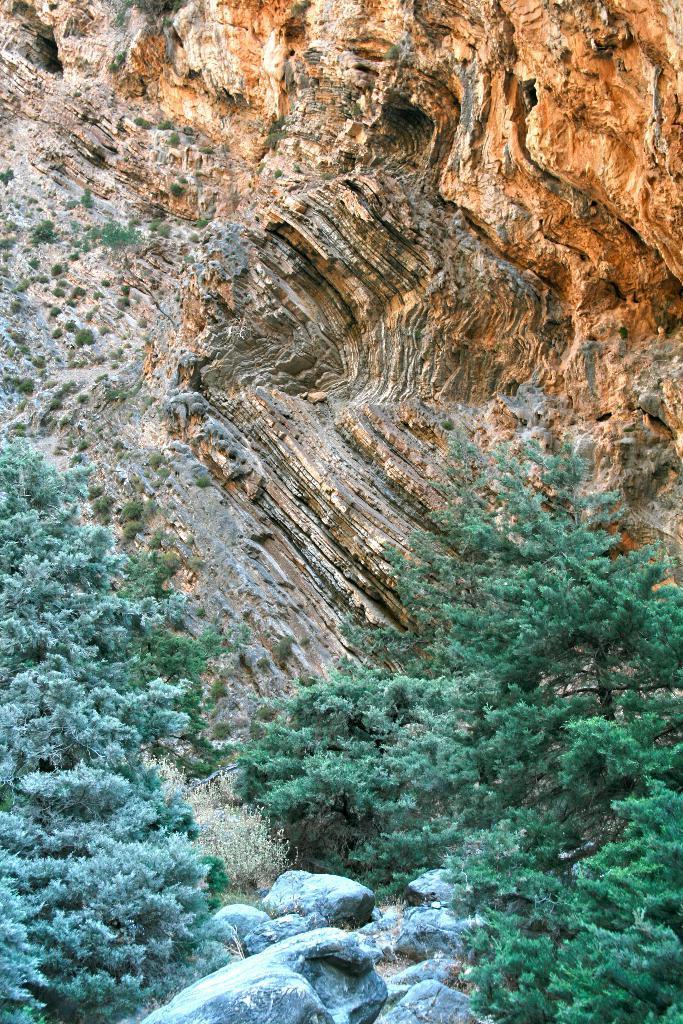Please provide a concise description of this image. In this picture I can see the stones and trees in the middle, at the top it looks like a hill. 